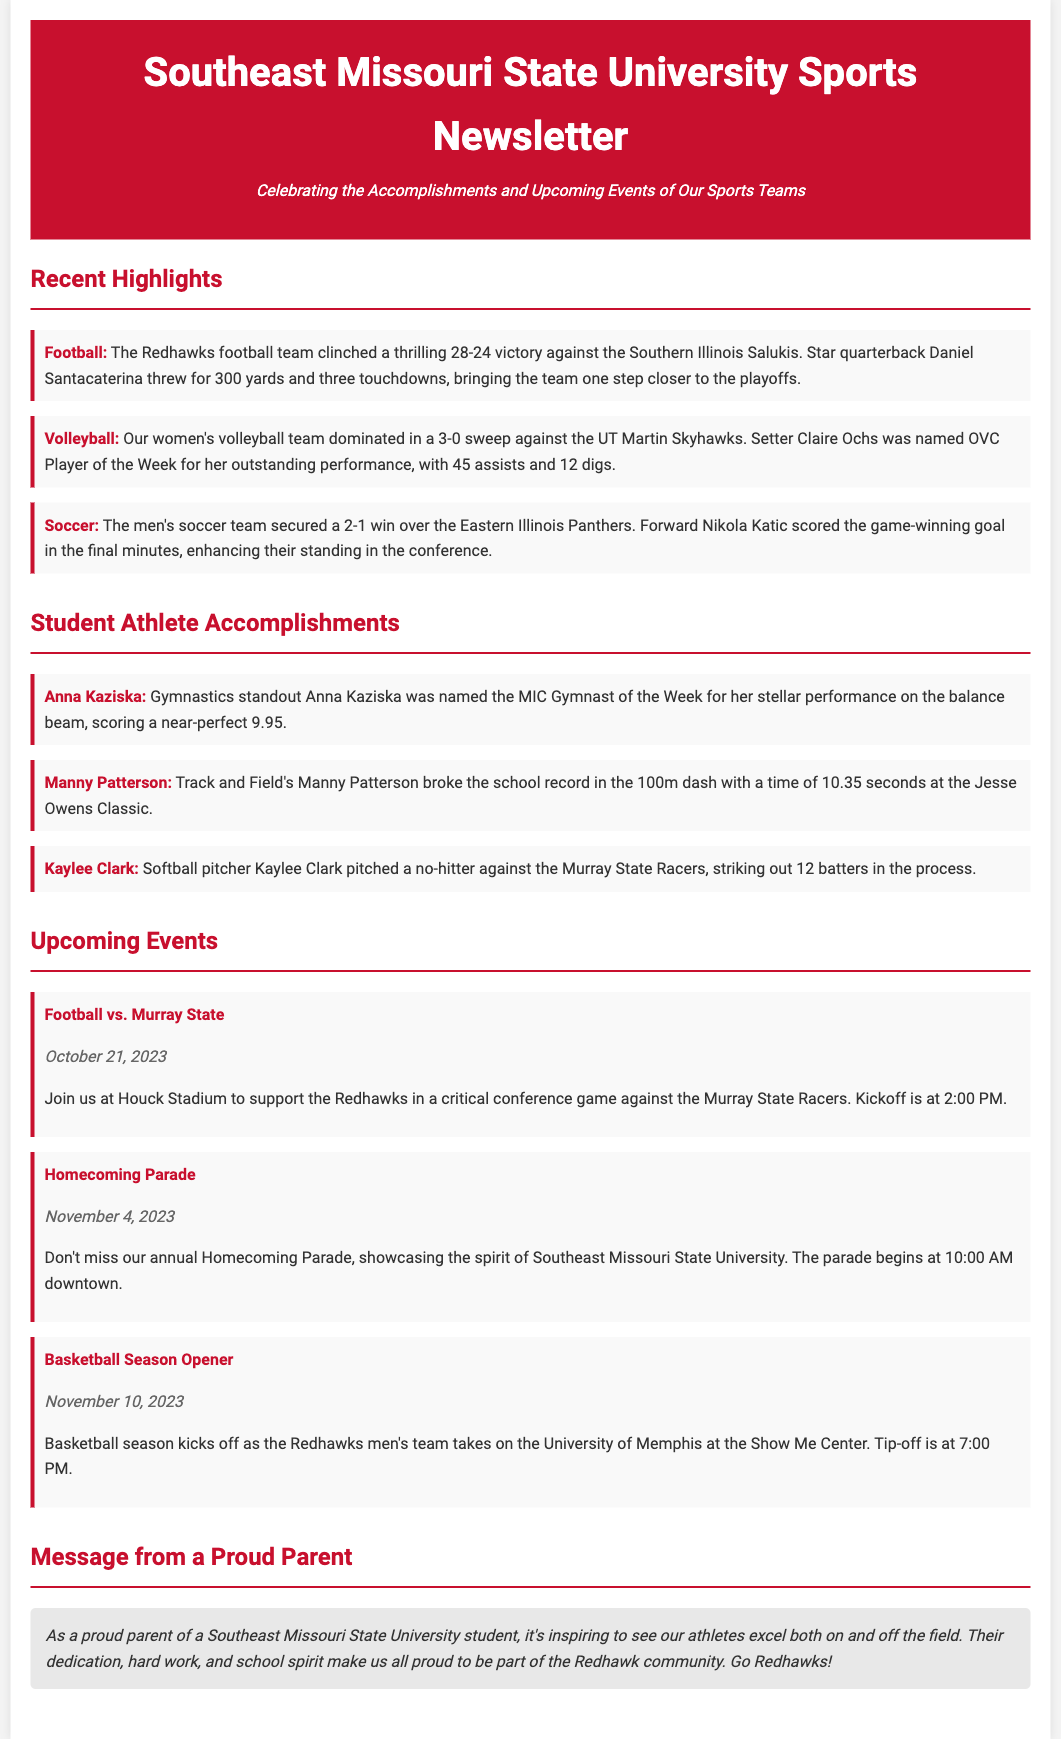what was the score of the football game against Southern Illinois? The document states the Redhawks football team won the game with a score of 28-24.
Answer: 28-24 who was named OVC Player of the Week in volleyball? The highlight mentions that setter Claire Ochs was named OVC Player of the Week for her performance.
Answer: Claire Ochs what significant achievement did Manny Patterson accomplish? The document notes that Manny Patterson broke the school record in the 100m dash with a time of 10.35 seconds.
Answer: broke the school record in the 100m dash when is the Homecoming Parade scheduled? The newsletter provides the date for the Homecoming Parade as November 4, 2023.
Answer: November 4, 2023 how did the men's soccer team secure their win? The document indicates that Nikola Katic scored the game-winning goal in the final minutes against Eastern Illinois.
Answer: game-winning goal in the final minutes 